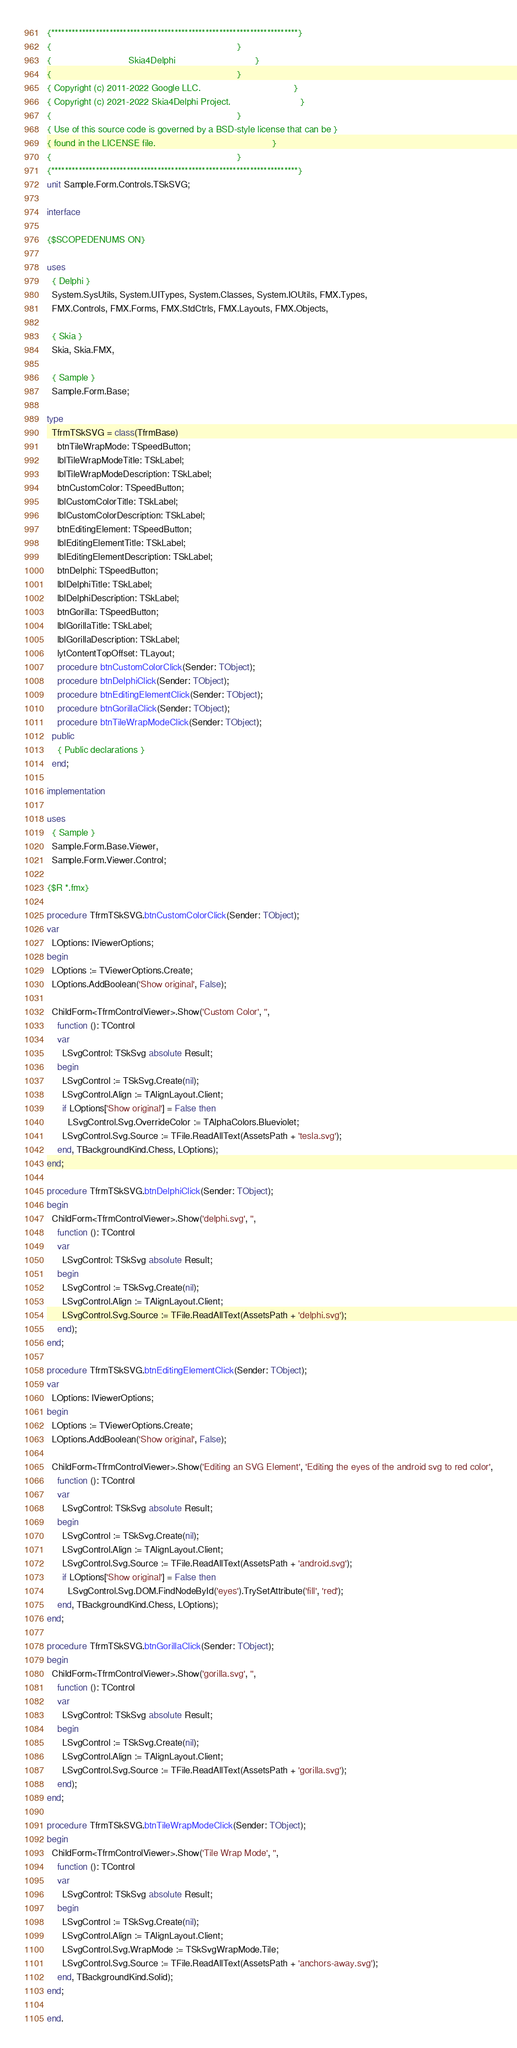<code> <loc_0><loc_0><loc_500><loc_500><_Pascal_>{************************************************************************}
{                                                                        }
{                              Skia4Delphi                               }
{                                                                        }
{ Copyright (c) 2011-2022 Google LLC.                                    }
{ Copyright (c) 2021-2022 Skia4Delphi Project.                           }
{                                                                        }
{ Use of this source code is governed by a BSD-style license that can be }
{ found in the LICENSE file.                                             }
{                                                                        }
{************************************************************************}
unit Sample.Form.Controls.TSkSVG;

interface

{$SCOPEDENUMS ON}

uses
  { Delphi }
  System.SysUtils, System.UITypes, System.Classes, System.IOUtils, FMX.Types,
  FMX.Controls, FMX.Forms, FMX.StdCtrls, FMX.Layouts, FMX.Objects,

  { Skia }
  Skia, Skia.FMX,

  { Sample }
  Sample.Form.Base;

type
  TfrmTSkSVG = class(TfrmBase)
    btnTileWrapMode: TSpeedButton;
    lblTileWrapModeTitle: TSkLabel;
    lblTileWrapModeDescription: TSkLabel;
    btnCustomColor: TSpeedButton;
    lblCustomColorTitle: TSkLabel;
    lblCustomColorDescription: TSkLabel;
    btnEditingElement: TSpeedButton;
    lblEditingElementTitle: TSkLabel;
    lblEditingElementDescription: TSkLabel;
    btnDelphi: TSpeedButton;
    lblDelphiTitle: TSkLabel;
    lblDelphiDescription: TSkLabel;
    btnGorilla: TSpeedButton;
    lblGorillaTitle: TSkLabel;
    lblGorillaDescription: TSkLabel;
    lytContentTopOffset: TLayout;
    procedure btnCustomColorClick(Sender: TObject);
    procedure btnDelphiClick(Sender: TObject);
    procedure btnEditingElementClick(Sender: TObject);
    procedure btnGorillaClick(Sender: TObject);
    procedure btnTileWrapModeClick(Sender: TObject);
  public
    { Public declarations }
  end;

implementation

uses
  { Sample }
  Sample.Form.Base.Viewer,
  Sample.Form.Viewer.Control;

{$R *.fmx}

procedure TfrmTSkSVG.btnCustomColorClick(Sender: TObject);
var
  LOptions: IViewerOptions;
begin
  LOptions := TViewerOptions.Create;
  LOptions.AddBoolean('Show original', False);

  ChildForm<TfrmControlViewer>.Show('Custom Color', '',
    function (): TControl
    var
      LSvgControl: TSkSvg absolute Result;
    begin
      LSvgControl := TSkSvg.Create(nil);
      LSvgControl.Align := TAlignLayout.Client;
      if LOptions['Show original'] = False then
        LSvgControl.Svg.OverrideColor := TAlphaColors.Blueviolet;
      LSvgControl.Svg.Source := TFile.ReadAllText(AssetsPath + 'tesla.svg');
    end, TBackgroundKind.Chess, LOptions);
end;

procedure TfrmTSkSVG.btnDelphiClick(Sender: TObject);
begin
  ChildForm<TfrmControlViewer>.Show('delphi.svg', '',
    function (): TControl
    var
      LSvgControl: TSkSvg absolute Result;
    begin
      LSvgControl := TSkSvg.Create(nil);
      LSvgControl.Align := TAlignLayout.Client;
      LSvgControl.Svg.Source := TFile.ReadAllText(AssetsPath + 'delphi.svg');
    end);
end;

procedure TfrmTSkSVG.btnEditingElementClick(Sender: TObject);
var
  LOptions: IViewerOptions;
begin
  LOptions := TViewerOptions.Create;
  LOptions.AddBoolean('Show original', False);

  ChildForm<TfrmControlViewer>.Show('Editing an SVG Element', 'Editing the eyes of the android svg to red color',
    function (): TControl
    var
      LSvgControl: TSkSvg absolute Result;
    begin
      LSvgControl := TSkSvg.Create(nil);
      LSvgControl.Align := TAlignLayout.Client;
      LSvgControl.Svg.Source := TFile.ReadAllText(AssetsPath + 'android.svg');
      if LOptions['Show original'] = False then
        LSvgControl.Svg.DOM.FindNodeById('eyes').TrySetAttribute('fill', 'red');
    end, TBackgroundKind.Chess, LOptions);
end;

procedure TfrmTSkSVG.btnGorillaClick(Sender: TObject);
begin
  ChildForm<TfrmControlViewer>.Show('gorilla.svg', '',
    function (): TControl
    var
      LSvgControl: TSkSvg absolute Result;
    begin
      LSvgControl := TSkSvg.Create(nil);
      LSvgControl.Align := TAlignLayout.Client;
      LSvgControl.Svg.Source := TFile.ReadAllText(AssetsPath + 'gorilla.svg');
    end);
end;

procedure TfrmTSkSVG.btnTileWrapModeClick(Sender: TObject);
begin
  ChildForm<TfrmControlViewer>.Show('Tile Wrap Mode', '',
    function (): TControl
    var
      LSvgControl: TSkSvg absolute Result;
    begin
      LSvgControl := TSkSvg.Create(nil);
      LSvgControl.Align := TAlignLayout.Client;
      LSvgControl.Svg.WrapMode := TSkSvgWrapMode.Tile;
      LSvgControl.Svg.Source := TFile.ReadAllText(AssetsPath + 'anchors-away.svg');
    end, TBackgroundKind.Solid);
end;

end.
</code> 